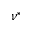<formula> <loc_0><loc_0><loc_500><loc_500>\nu ^ { * }</formula> 